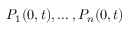<formula> <loc_0><loc_0><loc_500><loc_500>P _ { 1 } ( 0 , t ) , \dots , P _ { n } ( 0 , t )</formula> 